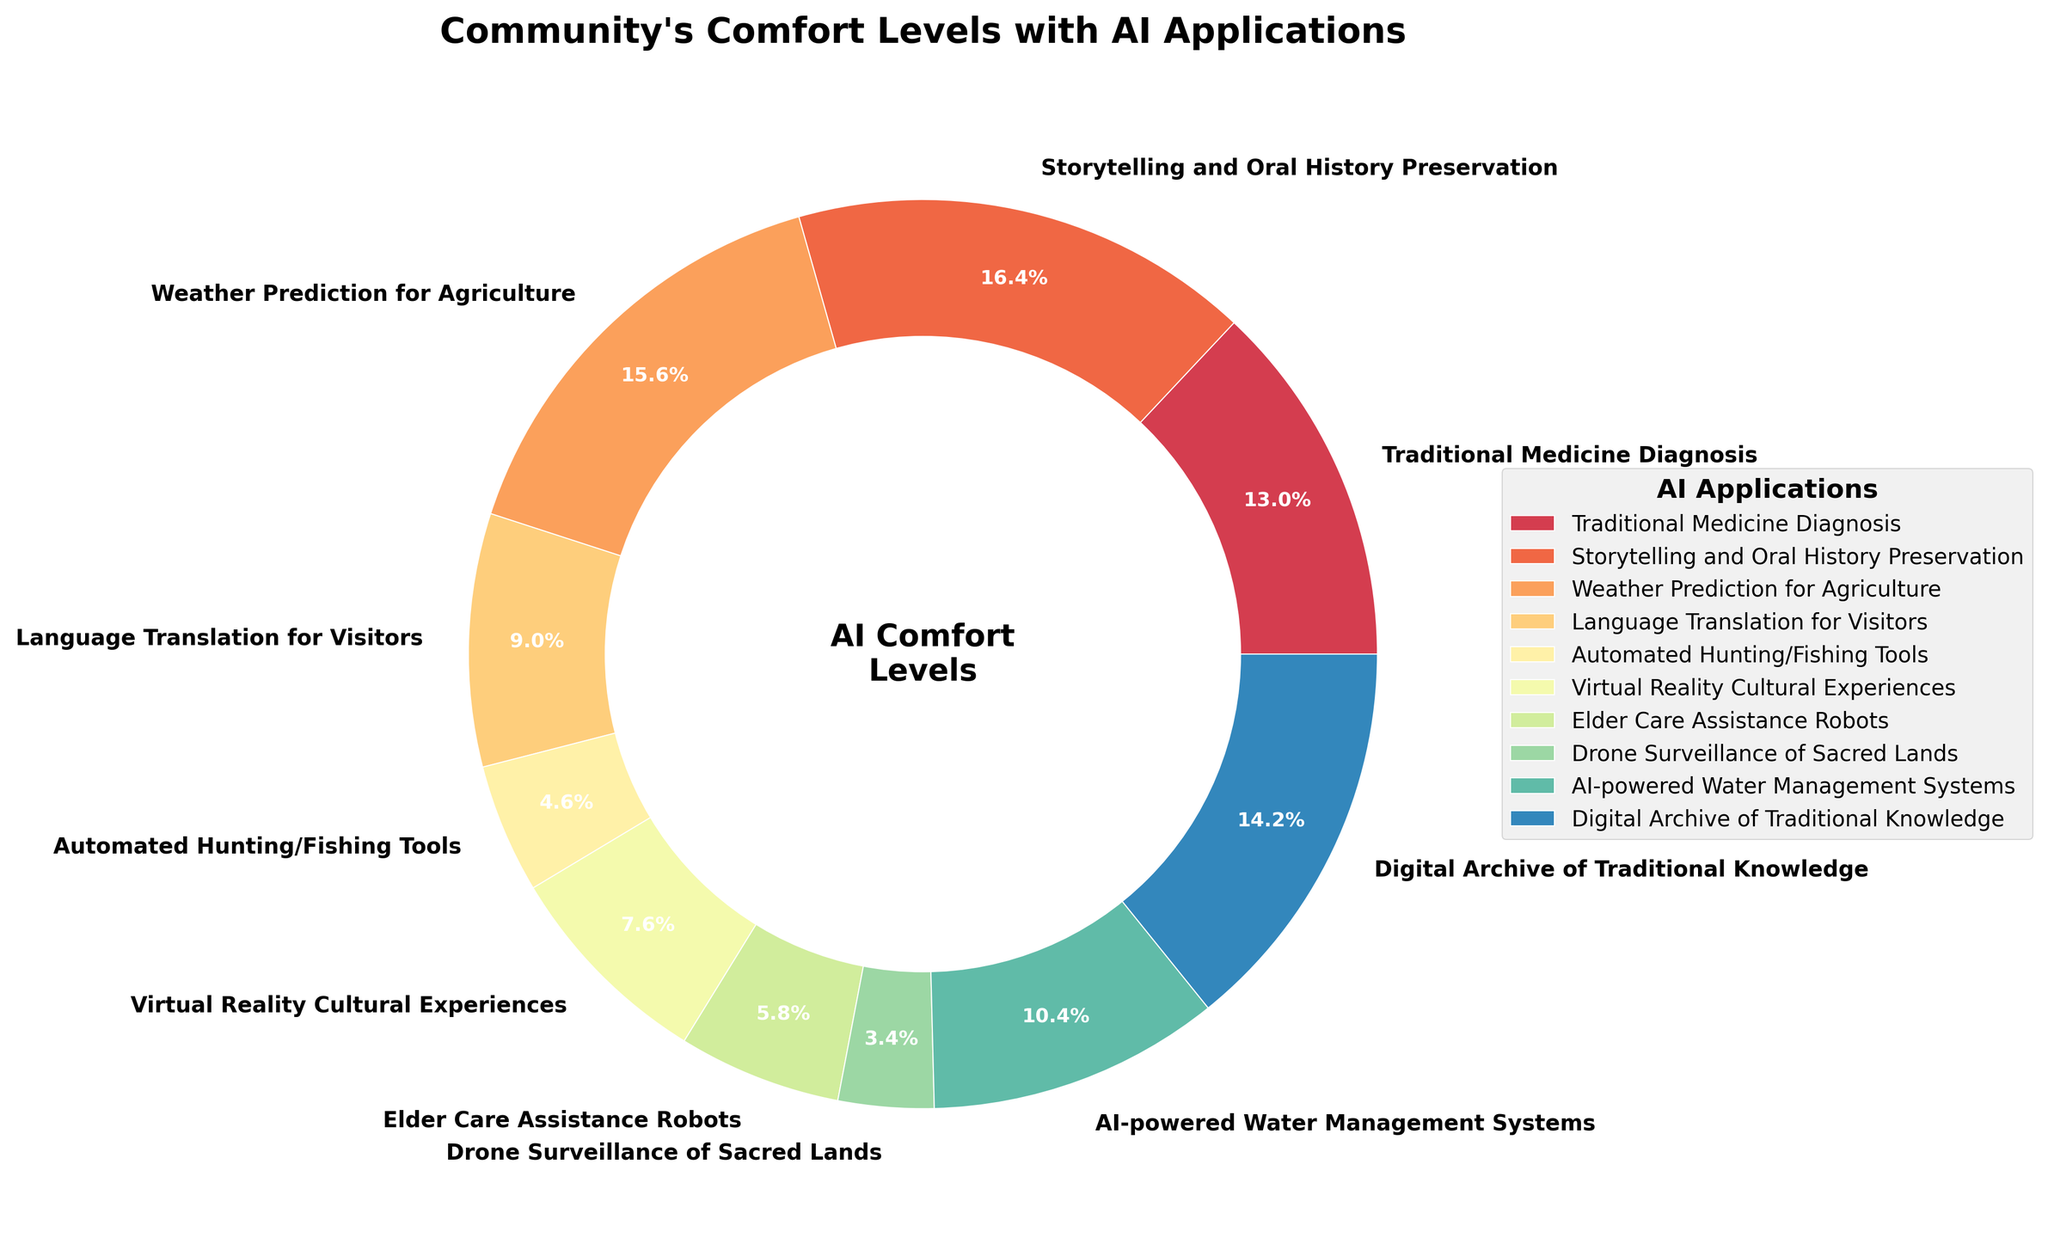Which AI application is the community most comfortable with? The pie chart shows the percentages of comfort levels for each AI application. By looking at the chart, the AI application with the highest percentage will be the one the community is most comfortable with.
Answer: Storytelling and Oral History Preservation Which AI application has the lowest comfort level? The pie chart shows the comfort levels for each AI application. By identifying the segment with the smallest percentage, we can find the AI application with the lowest comfort level.
Answer: Drone Surveillance of Sacred Lands What is the combined comfort level percentage for AI applications related to Traditional Medicine Diagnosis and Digital Archive of Traditional Knowledge? Add the comfort level percentages for Traditional Medicine Diagnosis (65%) and Digital Archive of Traditional Knowledge (71%). 65% + 71% = 136%
Answer: 136% Is the community more comfortable with using AI for Weather Prediction for Agriculture or Language Translation for Visitors? Compare the comfort level percentages for Weather Prediction for Agriculture (78%) and Language Translation for Visitors (45%). 78% is greater than 45%.
Answer: Weather Prediction for Agriculture What is the difference in comfort level between Virtual Reality Cultural Experiences and Elder Care Assistance Robots? Subtract the comfort level percentage of Elder Care Assistance Robots (29%) from Virtual Reality Cultural Experiences (38%). 38% - 29% = 9%
Answer: 9% What is the average comfort level for Automated Hunting/Fishing Tools, Virtual Reality Cultural Experiences, and Elder Care Assistance Robots? Add the comfort levels for Automated Hunting/Fishing Tools (23%), Virtual Reality Cultural Experiences (38%), and Elder Care Assistance Robots (29%), then divide by the number of applications (3). (23% + 38% + 29%) / 3 = 30%
Answer: 30% Which AI application has a comfort level between 30% and 60%? Looking at the chart, identify the segment whose percentage falls between 30% and 60%. AI-powered Water Management Systems at 52% falls in this range.
Answer: AI-powered Water Management Systems How much higher is the comfort level for Digital Archive of Traditional Knowledge compared to Automated Hunting/Fishing Tools? Subtract the comfort level percentage of Automated Hunting/Fishing Tools (23%) from Digital Archive of Traditional Knowledge (71%). 71% - 23% = 48%
Answer: 48% 